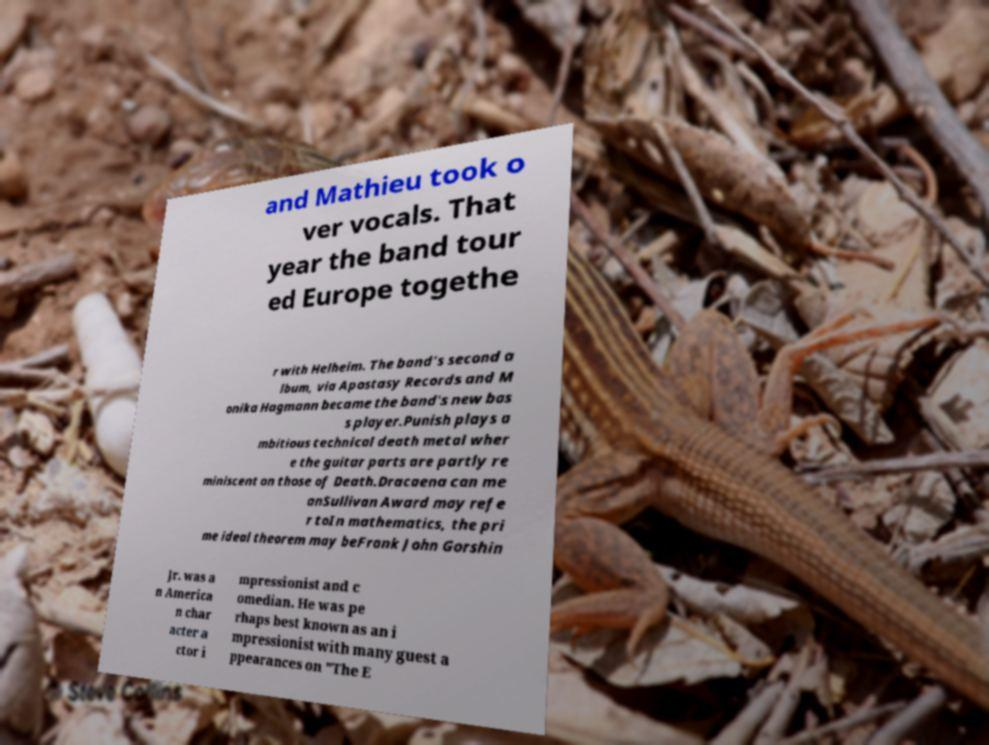What messages or text are displayed in this image? I need them in a readable, typed format. and Mathieu took o ver vocals. That year the band tour ed Europe togethe r with Helheim. The band’s second a lbum, via Apostasy Records and M onika Hagmann became the band's new bas s player.Punish plays a mbitious technical death metal wher e the guitar parts are partly re miniscent on those of Death.Dracaena can me anSullivan Award may refe r toIn mathematics, the pri me ideal theorem may beFrank John Gorshin Jr. was a n America n char acter a ctor i mpressionist and c omedian. He was pe rhaps best known as an i mpressionist with many guest a ppearances on "The E 